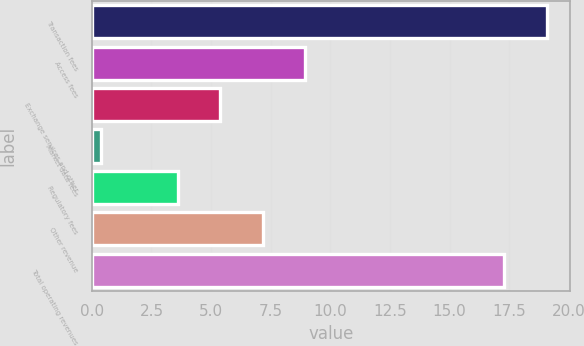<chart> <loc_0><loc_0><loc_500><loc_500><bar_chart><fcel>Transaction fees<fcel>Access fees<fcel>Exchange services and other<fcel>Market data fees<fcel>Regulatory fees<fcel>Other revenue<fcel>Total operating revenues<nl><fcel>19.08<fcel>8.94<fcel>5.38<fcel>0.4<fcel>3.6<fcel>7.16<fcel>17.3<nl></chart> 